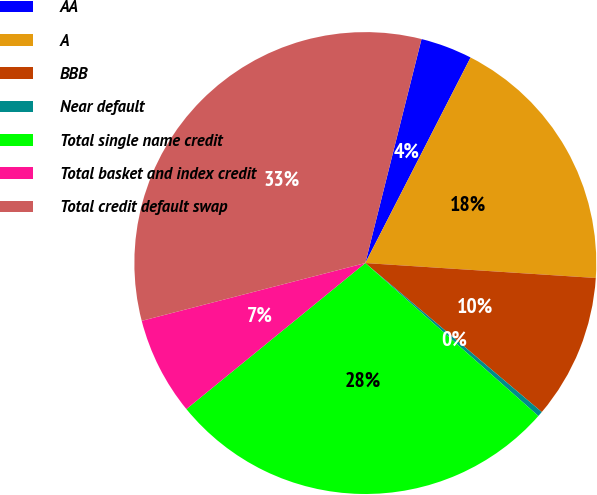Convert chart to OTSL. <chart><loc_0><loc_0><loc_500><loc_500><pie_chart><fcel>AA<fcel>A<fcel>BBB<fcel>Near default<fcel>Total single name credit<fcel>Total basket and index credit<fcel>Total credit default swap<nl><fcel>3.62%<fcel>18.5%<fcel>10.13%<fcel>0.36%<fcel>27.59%<fcel>6.87%<fcel>32.94%<nl></chart> 